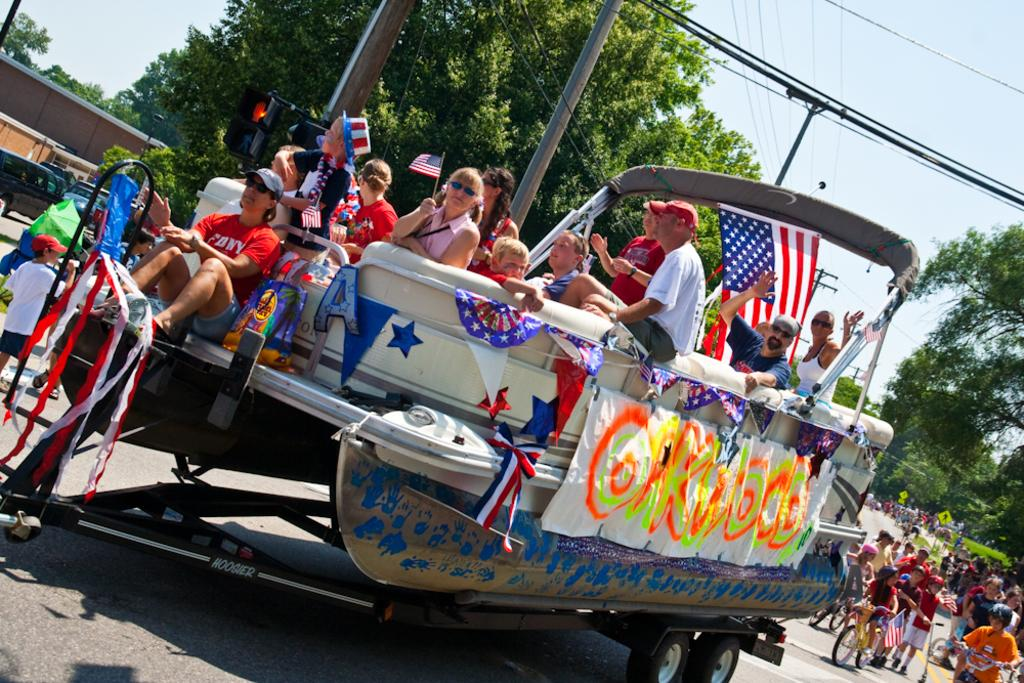<image>
Provide a brief description of the given image. A decorated boat on a tow for a parade, with a spray-painted sign on the side reading OAKWOOD. 